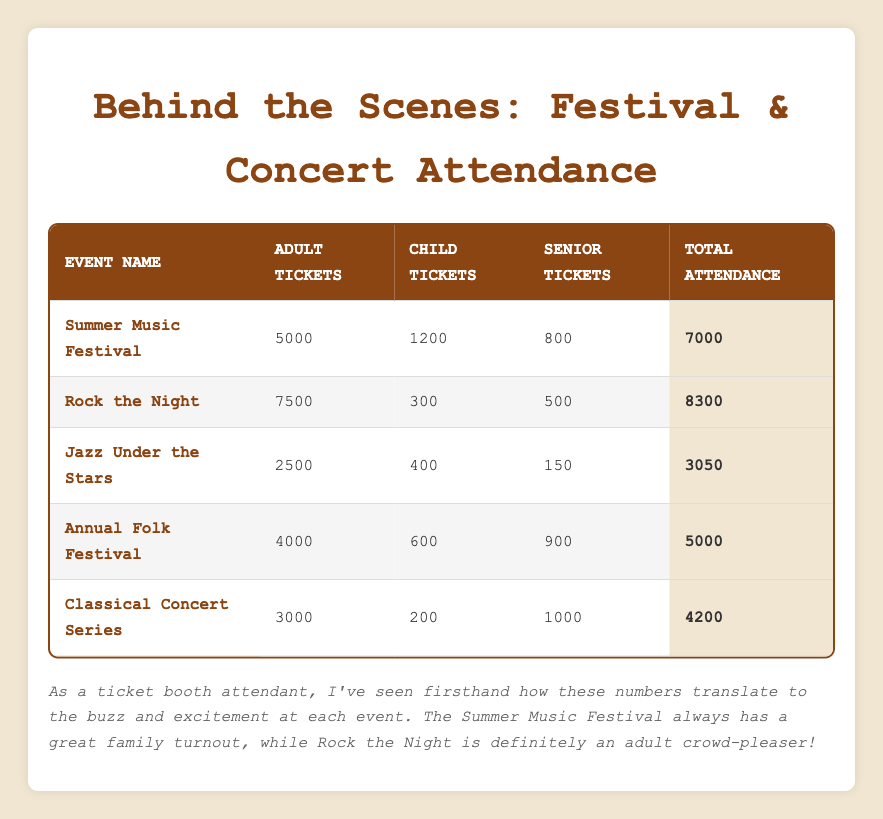What is the total attendance for the Rock the Night event? From the table, we can directly observe the row for Rock the Night, where Total Attendance is indicated. Therefore, it is 8300.
Answer: 8300 How many child tickets were sold for the Summer Music Festival? Looking at the row for the Summer Music Festival, we see that the number of Child Tickets Sold is listed as 1200.
Answer: 1200 Is the number of senior tickets sold for the Jazz Under the Stars greater than 200? The table states that for the Jazz Under the Stars event, Senior Tickets Sold amounts to 150. Since 150 is not greater than 200, the answer is no.
Answer: No What is the total number of adult tickets sold across all events? To find this, we sum the Adult Tickets Sold from each event: 5000 + 7500 + 2500 + 4000 + 3000 = 22000. This gives us the total number of adult tickets sold.
Answer: 22000 Which event had the highest attendance and how many total attendees were there? By checking the Total Attendance column, Rock the Night has the highest attendance at 8300. We need to compare this against the other events, and it is indeed the highest.
Answer: Rock the Night, 8300 What is the average number of child tickets sold for all events? To find the average, we first sum the Child Tickets Sold: 1200 + 300 + 400 + 600 + 200 = 2700. There are 5 events, so the average is 2700 / 5 = 540.
Answer: 540 Is it true that the Annual Folk Festival sold more senior tickets than the Classical Concert Series? The Annual Folk Festival sold 900 senior tickets while the Classical Concert Series sold 1000. Since 900 is less than 1000, the statement is false.
Answer: No How many more adult tickets were sold for the Rock the Night than the Summer Music Festival? For Rock the Night, Adult Tickets Sold is 7500, and for Summer Music Festival, it is 5000. The difference is 7500 - 5000 = 2500.
Answer: 2500 If all events sold a total of 28550 tickets, what percentage of that was from the Jazz Under the Stars? First, we find the total attendance for Jazz Under the Stars, which is 3050. The percentage can be calculated as (3050 / 28550) * 100. This gives us approximately 10.67%.
Answer: 10.67% 